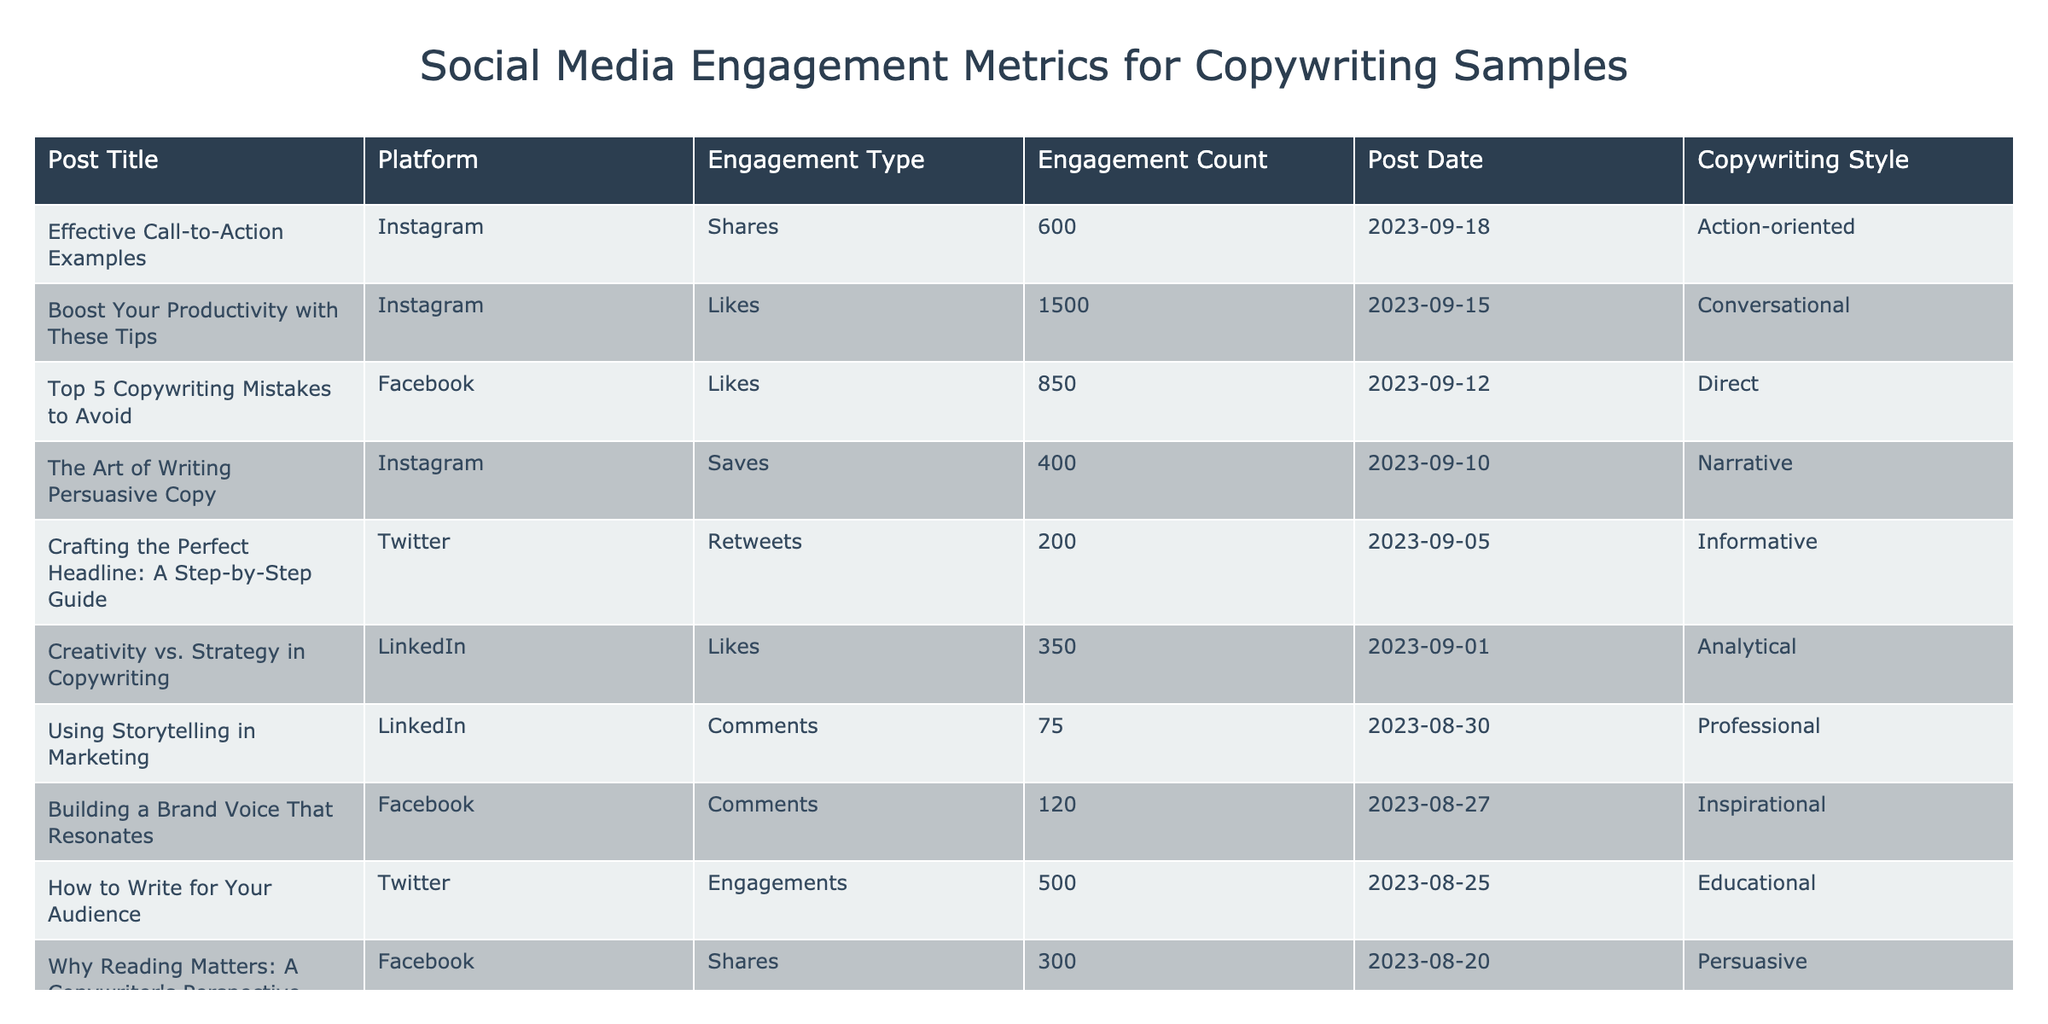What is the highest engagement count recorded in the table? The highest engagement count in the table is found by scanning through the "Engagement Count" column, where "Boost Your Productivity with These Tips" has a total of 1500 likes.
Answer: 1500 Which social media platform had the post with the most comments? The table shows "Using Storytelling in Marketing" on LinkedIn, which received 75 comments, making it the highest for comments among all posts listed.
Answer: LinkedIn What is the total engagement count of all posts on Instagram? To find the total engagement count for Instagram, sum the engagement counts for the posts with "Instagram" in the Platform column: 1500 (likes) + 400 (saves) + 600 (shares) = 2500.
Answer: 2500 Is there a post on Facebook that received more shares than likes? By looking at the Facebook posts, "Why Reading Matters: A Copywriter's Perspective" had 300 shares and "Top 5 Copywriting Mistakes to Avoid" had 850 likes. Thus, there is no Facebook post with more shares than likes.
Answer: No What is the average engagement count for the Twitter posts, and is it greater than 500? The Twitter posts are: "Crafting the Perfect Headline: A Step-by-Step Guide" (200), "How to Write for Your Audience" (500). Summing these, we get 200 + 500 = 700, and dividing by 2 gives an average of 350. Since 350 is less than 500, it is not greater.
Answer: No Which copywriting style had the lowest total engagement count across all posts? The engagement counts for each copywriting style are as follows: Conversational (1500), Persuasive (300), Informative (200), Professional (75), Narrative (400), Direct (850), Educational (500), Analytical (350), Action-oriented (600), Inspirational (120). The lowest total is for "Professional" with just 75 comments.
Answer: Professional How many posts on Facebook received engagement counts greater than 250? The Facebook posts are "Why Reading Matters: A Copywriter's Perspective" (300 shares), "Top 5 Copywriting Mistakes to Avoid" (850 likes), and "Building a Brand Voice That Resonates" (120 comments). Thus, there are 2 posts with engagement counts greater than 250.
Answer: 2 What is the difference between the engagement counts of the most and least liked posts? The most liked post on Instagram ("Boost Your Productivity with These Tips") has 1500 likes, while the least liked post on Facebook ("Building a Brand Voice That Resonates") has 120 comments. Therefore, the difference is calculated as 1500 - 120 = 1380.
Answer: 1380 Which two platforms have the highest and lowest total engagements combined? The total engagements are calculated for each platform: Instagram (2500), Facebook (1270), Twitter (700), LinkedIn (425). The highest total engagement is on Instagram (2500) and the lowest is LinkedIn (425).
Answer: Instagram and LinkedIn 